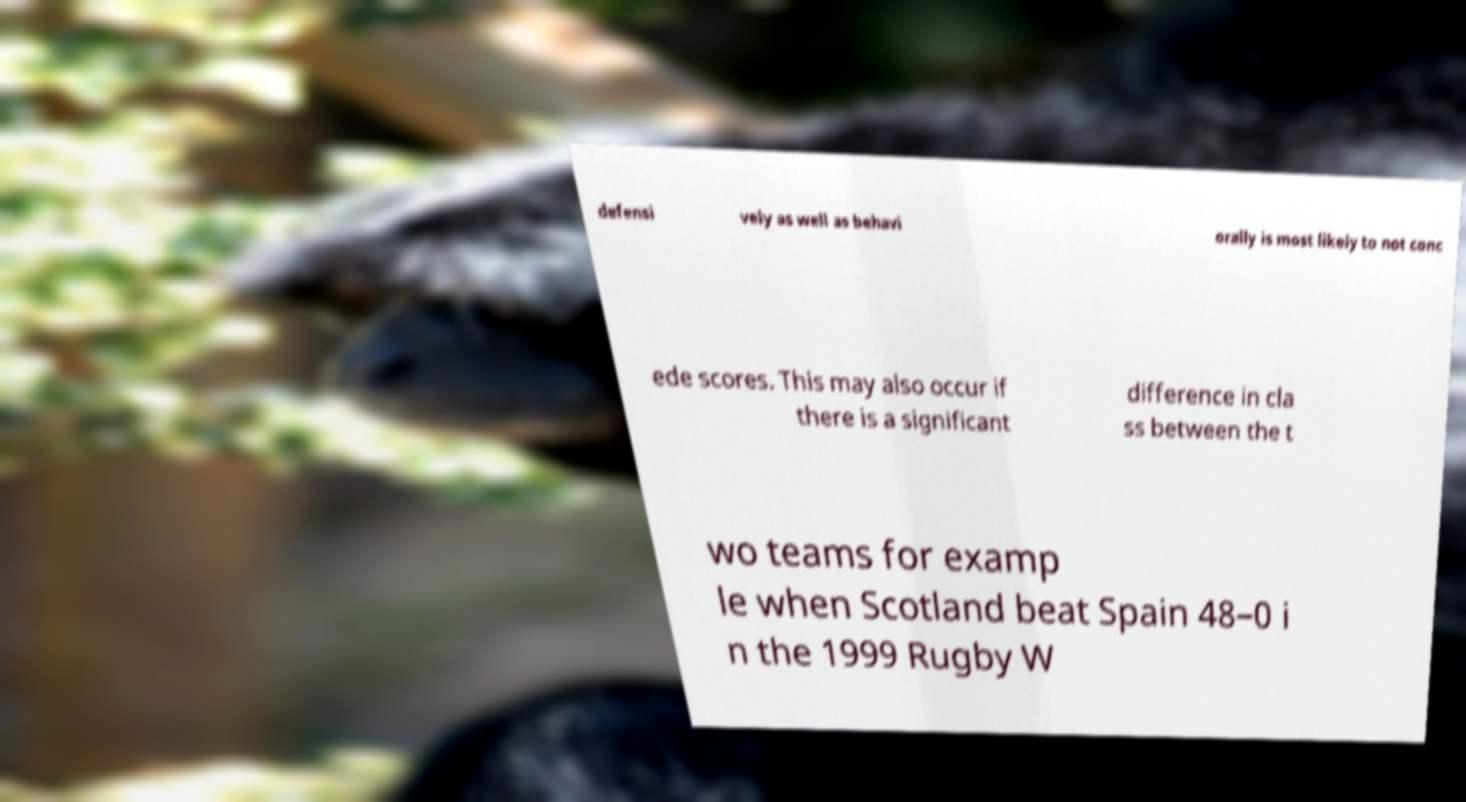What messages or text are displayed in this image? I need them in a readable, typed format. defensi vely as well as behavi orally is most likely to not conc ede scores. This may also occur if there is a significant difference in cla ss between the t wo teams for examp le when Scotland beat Spain 48–0 i n the 1999 Rugby W 